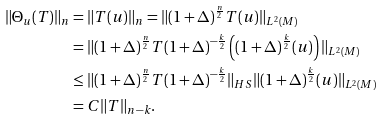<formula> <loc_0><loc_0><loc_500><loc_500>\| \Theta _ { u } ( T ) \| _ { n } & = \| T ( u ) \| _ { n } = \| ( 1 + \Delta ) ^ { \frac { n } { 2 } } T ( u ) \| _ { L ^ { 2 } ( M ) } \\ & = \| ( 1 + \Delta ) ^ { \frac { n } { 2 } } T ( 1 + \Delta ) ^ { - \frac { k } { 2 } } \left ( ( 1 + \Delta ) ^ { \frac { k } { 2 } } ( u ) \right ) \| _ { L ^ { 2 } ( M ) } \\ & \leq \| ( 1 + \Delta ) ^ { \frac { n } { 2 } } T ( 1 + \Delta ) ^ { - \frac { k } { 2 } } \| _ { H S } \| ( 1 + \Delta ) ^ { \frac { k } { 2 } } ( u ) \| _ { L ^ { 2 } ( M ) } \\ & = C \| T \| _ { n - k } .</formula> 